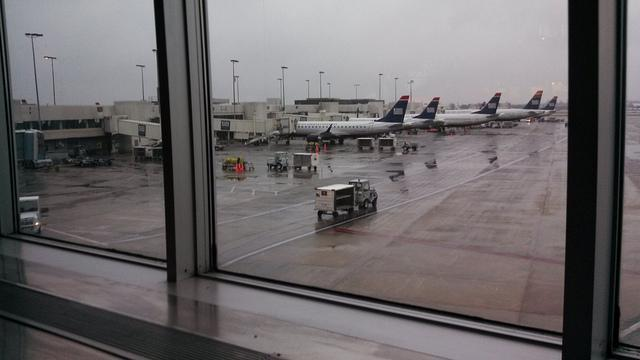What would be the most likely cause of a travel delay for this airport? rain 